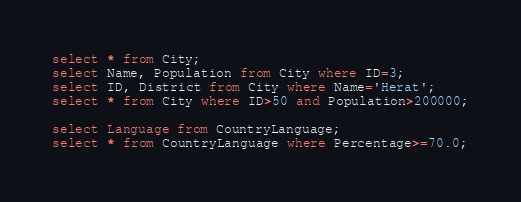<code> <loc_0><loc_0><loc_500><loc_500><_SQL_>select * from City;
select Name, Population from City where ID=3;
select ID, District from City where Name='Herat';
select * from City where ID>50 and Population>200000;

select Language from CountryLanguage;
select * from CountryLanguage where Percentage>=70.0;</code> 